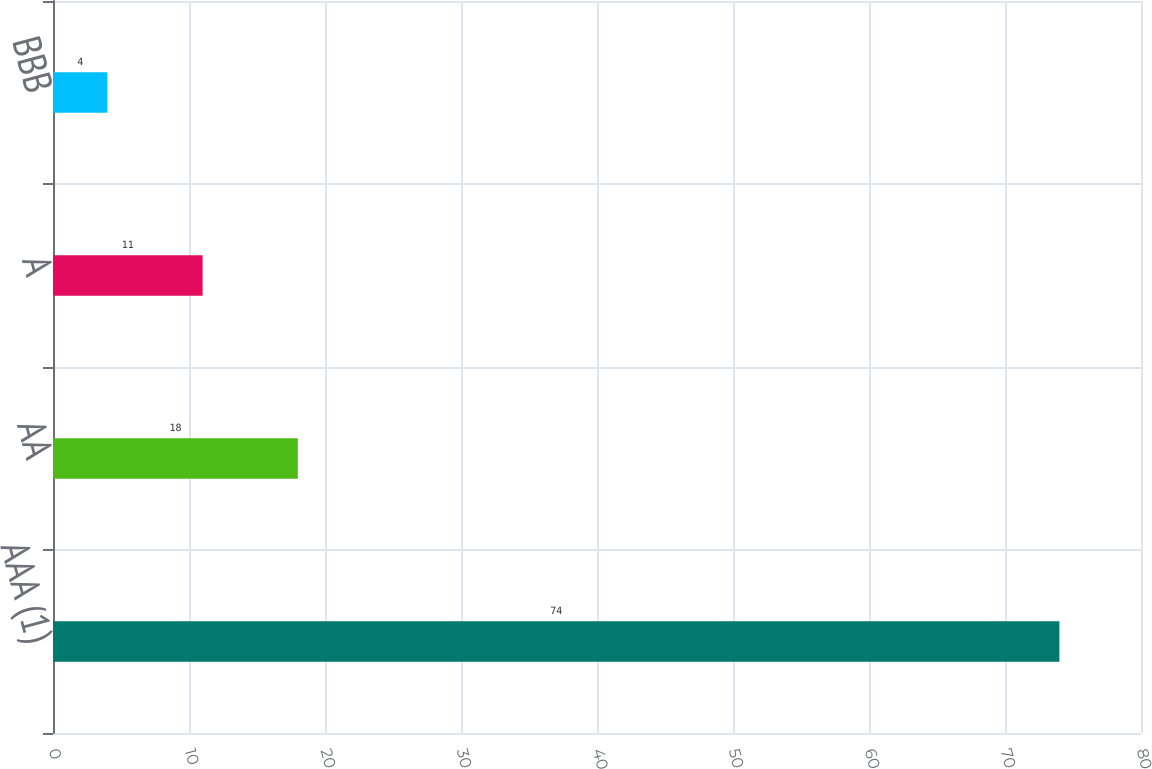Convert chart to OTSL. <chart><loc_0><loc_0><loc_500><loc_500><bar_chart><fcel>AAA (1)<fcel>AA<fcel>A<fcel>BBB<nl><fcel>74<fcel>18<fcel>11<fcel>4<nl></chart> 